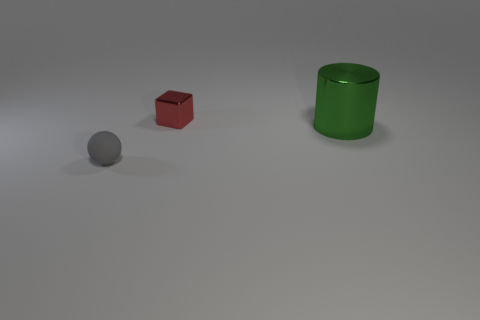Is the tiny thing behind the rubber thing made of the same material as the object that is right of the red metal thing?
Provide a succinct answer. Yes. What size is the object that is behind the big metallic thing to the right of the tiny red cube behind the big green cylinder?
Your answer should be very brief. Small. There is a gray sphere that is the same size as the red metallic block; what material is it?
Ensure brevity in your answer.  Rubber. Are there any blue rubber cylinders of the same size as the red shiny object?
Make the answer very short. No. Is the red metal thing the same shape as the rubber object?
Make the answer very short. No. Are there any gray rubber balls that are behind the object that is to the right of the small thing that is behind the sphere?
Ensure brevity in your answer.  No. Is the size of the thing to the left of the small red block the same as the object behind the green cylinder?
Ensure brevity in your answer.  Yes. Are there an equal number of small gray objects behind the gray rubber ball and large green cylinders in front of the large green metallic cylinder?
Your answer should be very brief. Yes. Is there any other thing that is the same material as the small gray ball?
Provide a succinct answer. No. There is a gray rubber object; does it have the same size as the thing that is behind the large green object?
Provide a short and direct response. Yes. 